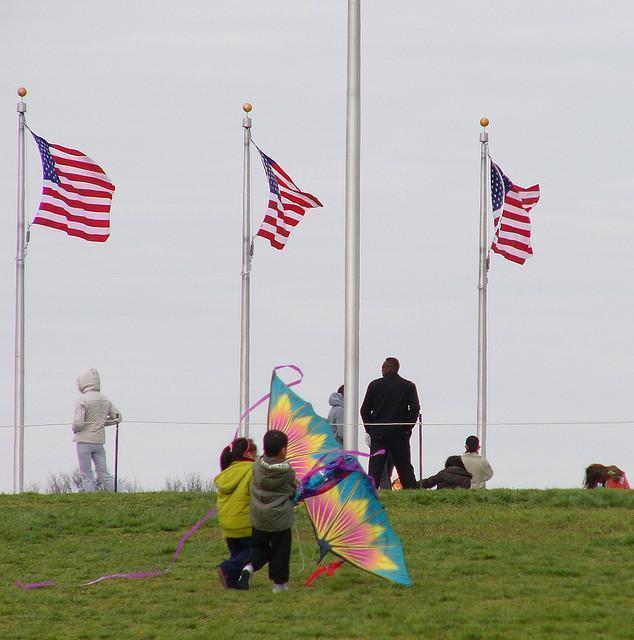What are the silver poles being used for?
Choose the right answer and clarify with the format: 'Answer: answer
Rationale: rationale.'
Options: Flying flags, climbing, flinging, swinging. Answer: flying flags.
Rationale: Due to wind, flag poles need to be sturdy. the poles pictured are tall, silver, and sturdy; perfect for displaying flags. 